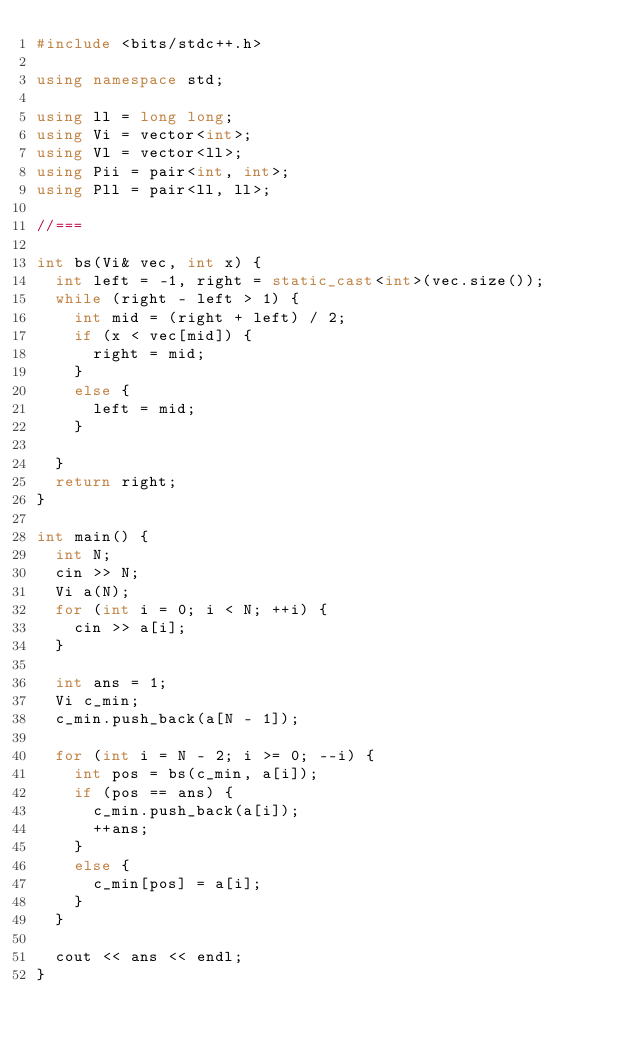Convert code to text. <code><loc_0><loc_0><loc_500><loc_500><_C++_>#include <bits/stdc++.h>

using namespace std;

using ll = long long;
using Vi = vector<int>;
using Vl = vector<ll>;
using Pii = pair<int, int>;
using Pll = pair<ll, ll>;

//===

int bs(Vi& vec, int x) {
	int left = -1, right = static_cast<int>(vec.size());
	while (right - left > 1) {
		int mid = (right + left) / 2;
		if (x < vec[mid]) {
			right = mid;
		}
		else {
			left = mid;
		}

	}
	return right;
}

int main() {
	int N;
	cin >> N;
	Vi a(N);
	for (int i = 0; i < N; ++i) {
		cin >> a[i];
	}

	int ans = 1;
	Vi c_min;
	c_min.push_back(a[N - 1]);

	for (int i = N - 2; i >= 0; --i) {
		int pos = bs(c_min, a[i]);
		if (pos == ans) {
			c_min.push_back(a[i]);
			++ans;
		}
		else {
			c_min[pos] = a[i];
		}
	}

	cout << ans << endl;
}</code> 